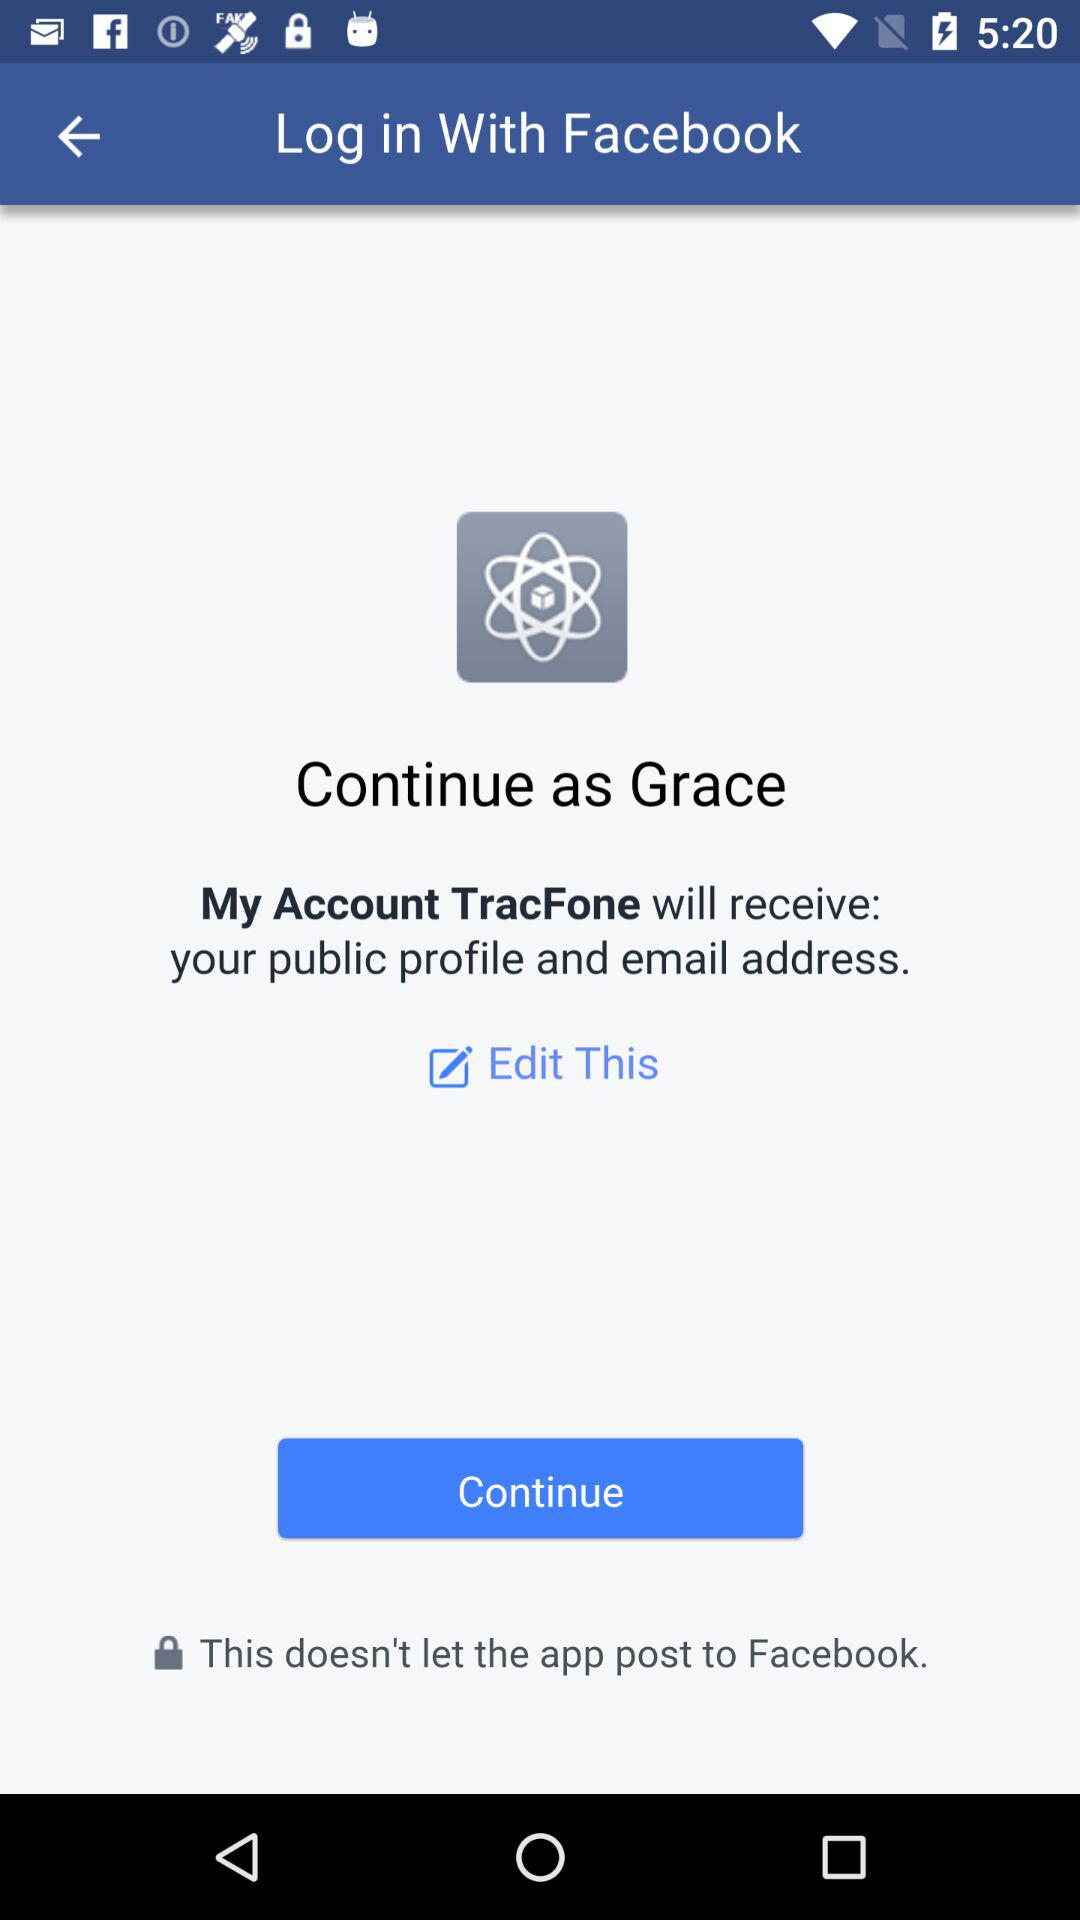What account can be used to continue logging in? The account that can be used to continue logging in is "Facebook". 